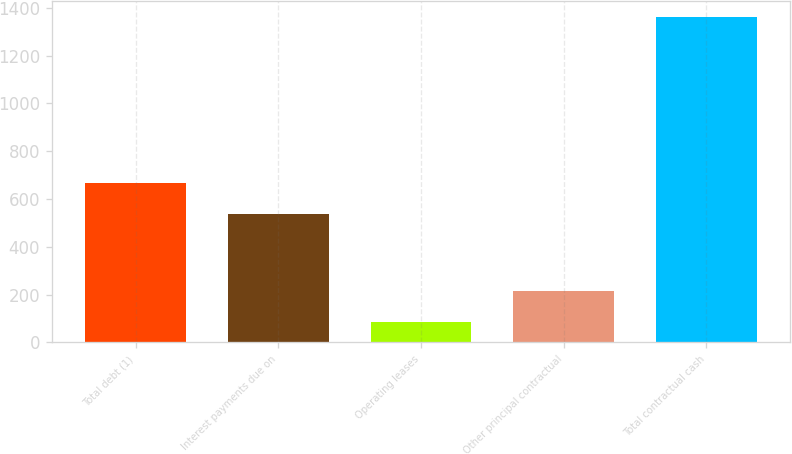<chart> <loc_0><loc_0><loc_500><loc_500><bar_chart><fcel>Total debt (1)<fcel>Interest payments due on<fcel>Operating leases<fcel>Other principal contractual<fcel>Total contractual cash<nl><fcel>667.12<fcel>539.5<fcel>85.8<fcel>213.42<fcel>1362<nl></chart> 